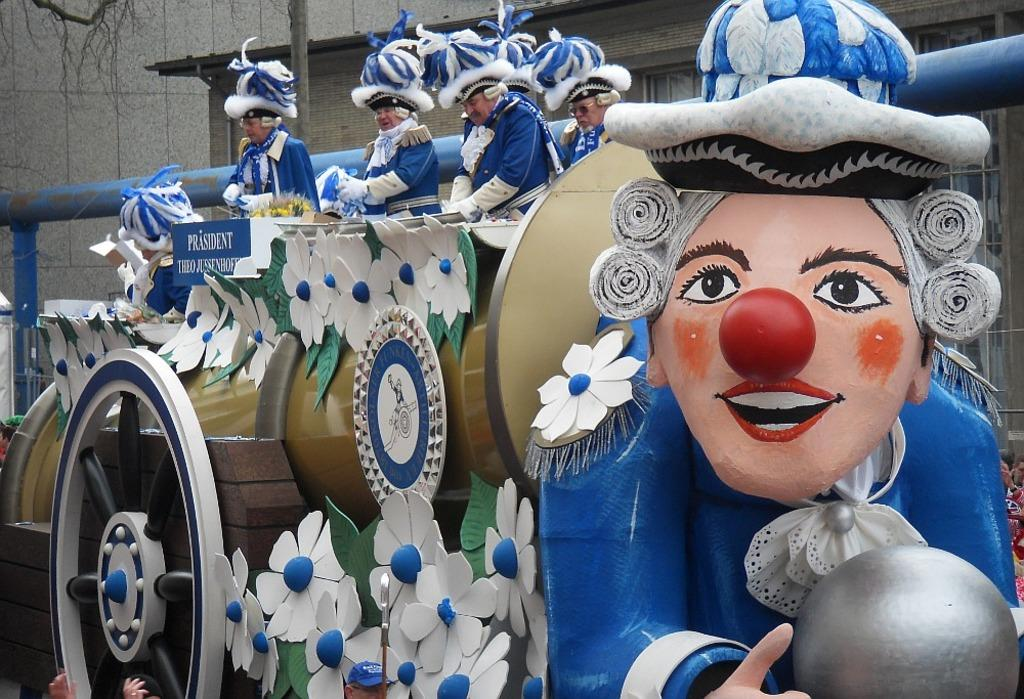How many people are in the image? There is a group of people in the image. What are the people wearing on their heads? The people are wearing hats. What can be seen in the image besides the people? There are decorative items in the image. What is visible in the background of the image? There is a house with glass windows in the background. What object can be seen standing upright in the image? There is a pole in the image. What type of milk is being served in the image? There is no milk present in the image. How do the people react to the bell in the image? There is no bell present in the image. 